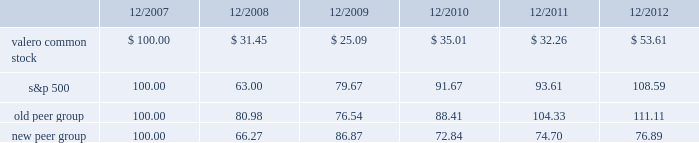Table of contents the following performance graph is not 201csoliciting material , 201d is not deemed filed with the sec , and is not to be incorporated by reference into any of valero 2019s filings under the securities act of 1933 or the securities exchange act of 1934 , as amended , respectively .
This performance graph and the related textual information are based on historical data and are not indicative of future performance .
The following line graph compares the cumulative total return 1 on an investment in our common stock against the cumulative total return of the s&p 500 composite index and an index of peer companies ( that we selected ) for the five-year period commencing december 31 , 2007 and ending december 31 , 2012 .
Our peer group consists of the following ten companies : alon usa energy , inc. ; bp plc ( bp ) ; cvr energy , inc. ; hess corporation ; hollyfrontier corporation ; marathon petroleum corporation ; phillips 66 ( psx ) ; royal dutch shell plc ( rds ) ; tesoro corporation ; and western refining , inc .
Our peer group previously included chevron corporation ( cvx ) and exxon mobil corporation ( xom ) but they were replaced with bp , psx , and rds .
In 2012 , psx became an independent downstream energy company and was added to our peer group .
Cvx and xom were replaced with bp and rds as they were viewed as having operations that more closely aligned with our core businesses .
Comparison of 5 year cumulative total return1 among valero energy corporation , the s&p 500 index , old peer group , and new peer group .
____________ 1 assumes that an investment in valero common stock and each index was $ 100 on december 31 , 2007 .
201ccumulative total return 201d is based on share price appreciation plus reinvestment of dividends from december 31 , 2007 through december 31 , 2012. .
What was the biggest decline , in percentage , from 2007-2008 , among the four groups? 
Computations: ((100 - 31.45) / 100)
Answer: 0.6855. Table of contents the following performance graph is not 201csoliciting material , 201d is not deemed filed with the sec , and is not to be incorporated by reference into any of valero 2019s filings under the securities act of 1933 or the securities exchange act of 1934 , as amended , respectively .
This performance graph and the related textual information are based on historical data and are not indicative of future performance .
The following line graph compares the cumulative total return 1 on an investment in our common stock against the cumulative total return of the s&p 500 composite index and an index of peer companies ( that we selected ) for the five-year period commencing december 31 , 2007 and ending december 31 , 2012 .
Our peer group consists of the following ten companies : alon usa energy , inc. ; bp plc ( bp ) ; cvr energy , inc. ; hess corporation ; hollyfrontier corporation ; marathon petroleum corporation ; phillips 66 ( psx ) ; royal dutch shell plc ( rds ) ; tesoro corporation ; and western refining , inc .
Our peer group previously included chevron corporation ( cvx ) and exxon mobil corporation ( xom ) but they were replaced with bp , psx , and rds .
In 2012 , psx became an independent downstream energy company and was added to our peer group .
Cvx and xom were replaced with bp and rds as they were viewed as having operations that more closely aligned with our core businesses .
Comparison of 5 year cumulative total return1 among valero energy corporation , the s&p 500 index , old peer group , and new peer group .
____________ 1 assumes that an investment in valero common stock and each index was $ 100 on december 31 , 2007 .
201ccumulative total return 201d is based on share price appreciation plus reinvestment of dividends from december 31 , 2007 through december 31 , 2012. .
What was the mathematical range for all four groups in 12/2010 , assuming investments of $ 100 initially in 2008? 
Computations: (91.67 - 35.01)
Answer: 56.66. 